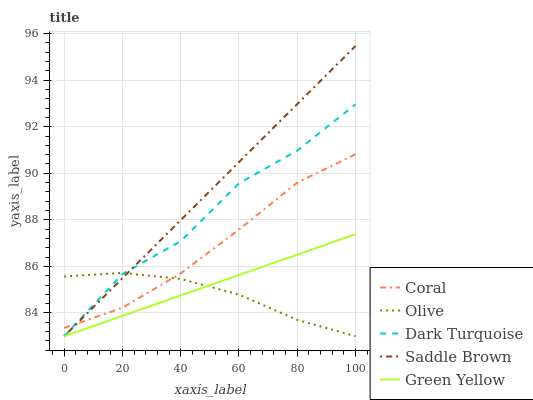Does Olive have the minimum area under the curve?
Answer yes or no. Yes. Does Saddle Brown have the maximum area under the curve?
Answer yes or no. Yes. Does Dark Turquoise have the minimum area under the curve?
Answer yes or no. No. Does Dark Turquoise have the maximum area under the curve?
Answer yes or no. No. Is Green Yellow the smoothest?
Answer yes or no. Yes. Is Dark Turquoise the roughest?
Answer yes or no. Yes. Is Coral the smoothest?
Answer yes or no. No. Is Coral the roughest?
Answer yes or no. No. Does Olive have the lowest value?
Answer yes or no. Yes. Does Coral have the lowest value?
Answer yes or no. No. Does Saddle Brown have the highest value?
Answer yes or no. Yes. Does Dark Turquoise have the highest value?
Answer yes or no. No. Is Green Yellow less than Coral?
Answer yes or no. Yes. Is Coral greater than Green Yellow?
Answer yes or no. Yes. Does Green Yellow intersect Saddle Brown?
Answer yes or no. Yes. Is Green Yellow less than Saddle Brown?
Answer yes or no. No. Is Green Yellow greater than Saddle Brown?
Answer yes or no. No. Does Green Yellow intersect Coral?
Answer yes or no. No. 